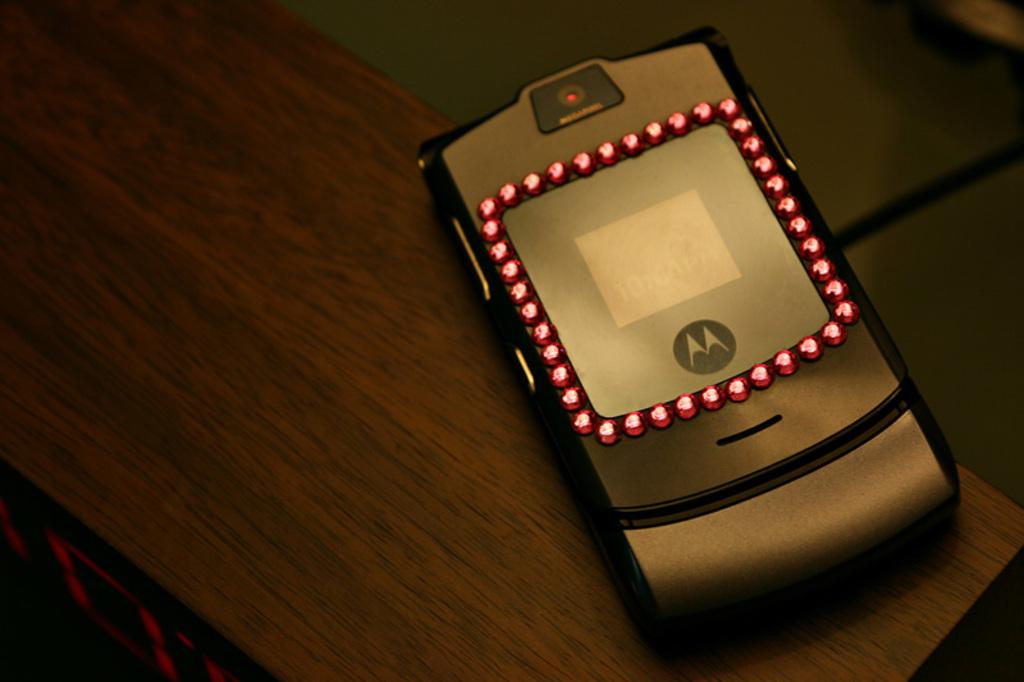What is the main object located on the platform in the image? There is a mobile on a platform in the image. What might be the purpose of the mobile on the platform? The mobile on the platform might be for decoration or as a focal point in the room. Can you describe the platform on which the mobile is placed? The platform is not described in the provided facts, so it cannot be definitively described. What type of cap is being used to cut the vegetables in the image? There is no cap or vegetables present in the image; it features a mobile on a platform. 